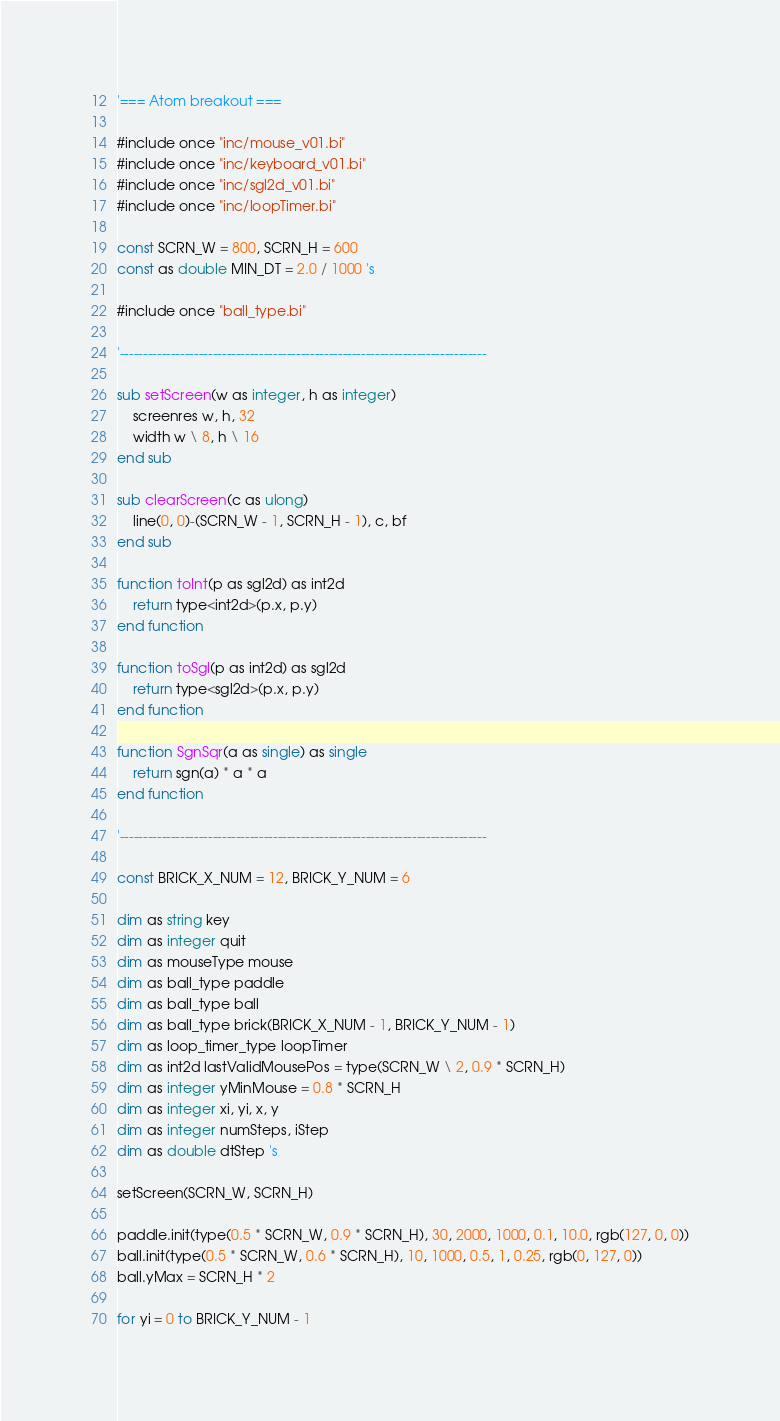Convert code to text. <code><loc_0><loc_0><loc_500><loc_500><_VisualBasic_>'=== Atom breakout ===

#include once "inc/mouse_v01.bi"
#include once "inc/keyboard_v01.bi"
#include once "inc/sgl2d_v01.bi"
#include once "inc/loopTimer.bi"

const SCRN_W = 800, SCRN_H = 600
const as double MIN_DT = 2.0 / 1000 's

#include once "ball_type.bi"

'-------------------------------------------------------------------------------

sub setScreen(w as integer, h as integer)
	screenres w, h, 32
	width w \ 8, h \ 16
end sub

sub clearScreen(c as ulong)
	line(0, 0)-(SCRN_W - 1, SCRN_H - 1), c, bf
end sub

function toInt(p as sgl2d) as int2d
	return type<int2d>(p.x, p.y)
end function

function toSgl(p as int2d) as sgl2d
	return type<sgl2d>(p.x, p.y)
end function

function SgnSqr(a as single) as single
	return sgn(a) * a * a
end function

'-------------------------------------------------------------------------------

const BRICK_X_NUM = 12, BRICK_Y_NUM = 6

dim as string key
dim as integer quit
dim as mouseType mouse
dim as ball_type paddle
dim as ball_type ball
dim as ball_type brick(BRICK_X_NUM - 1, BRICK_Y_NUM - 1)
dim as loop_timer_type loopTimer
dim as int2d lastValidMousePos = type(SCRN_W \ 2, 0.9 * SCRN_H)
dim as integer yMinMouse = 0.8 * SCRN_H
dim as integer xi, yi, x, y
dim as integer numSteps, iStep
dim as double dtStep 's

setScreen(SCRN_W, SCRN_H)

paddle.init(type(0.5 * SCRN_W, 0.9 * SCRN_H), 30, 2000, 1000, 0.1, 10.0, rgb(127, 0, 0))
ball.init(type(0.5 * SCRN_W, 0.6 * SCRN_H), 10, 1000, 0.5, 1, 0.25, rgb(0, 127, 0))
ball.yMax = SCRN_H * 2

for yi = 0 to BRICK_Y_NUM - 1</code> 